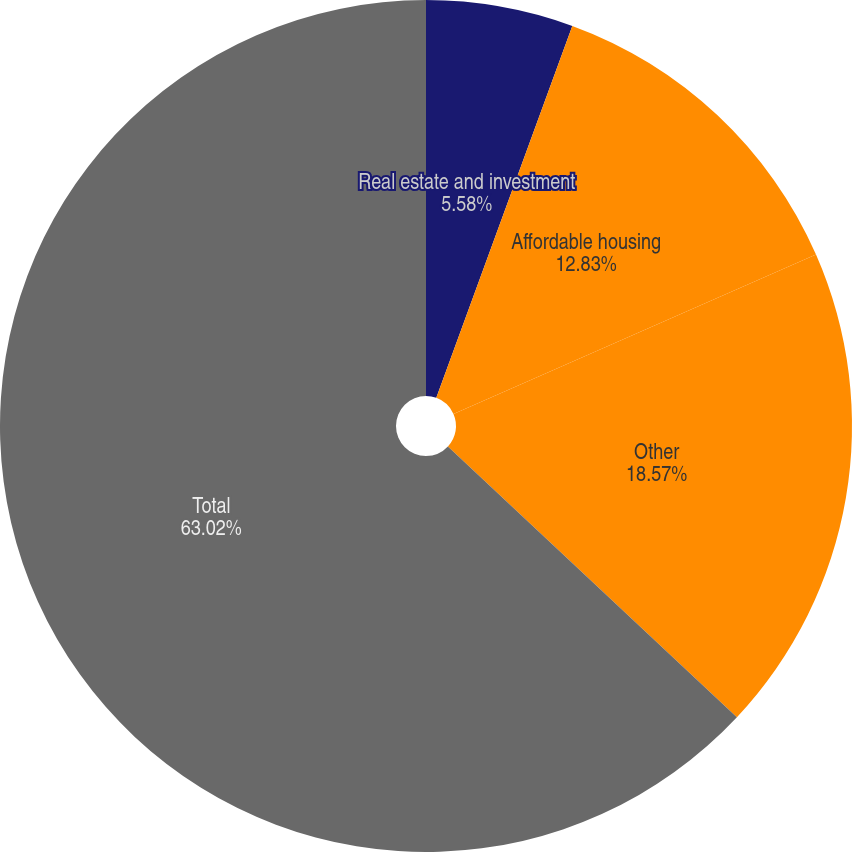<chart> <loc_0><loc_0><loc_500><loc_500><pie_chart><fcel>Real estate and investment<fcel>Affordable housing<fcel>Other<fcel>Total<nl><fcel>5.58%<fcel>12.83%<fcel>18.57%<fcel>63.02%<nl></chart> 